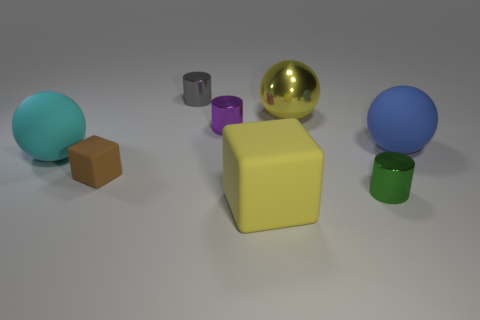Is there a green metallic thing of the same size as the purple cylinder?
Give a very brief answer. Yes. What material is the tiny cylinder that is in front of the large object left of the big rubber cube?
Provide a short and direct response. Metal. How many rubber spheres are the same color as the tiny matte block?
Offer a terse response. 0. There is a small purple object that is the same material as the gray object; what is its shape?
Your answer should be compact. Cylinder. What is the size of the yellow object behind the blue rubber object?
Keep it short and to the point. Large. Are there an equal number of big yellow objects in front of the small green thing and small gray objects to the right of the big yellow ball?
Ensure brevity in your answer.  No. There is a large matte object that is behind the large object that is on the left side of the large yellow object that is in front of the brown matte block; what color is it?
Give a very brief answer. Blue. How many small shiny cylinders are in front of the small brown rubber block and to the left of the tiny purple cylinder?
Ensure brevity in your answer.  0. There is a big rubber thing in front of the green shiny cylinder; is its color the same as the sphere behind the blue sphere?
Give a very brief answer. Yes. What is the size of the yellow metallic thing that is the same shape as the cyan thing?
Ensure brevity in your answer.  Large. 